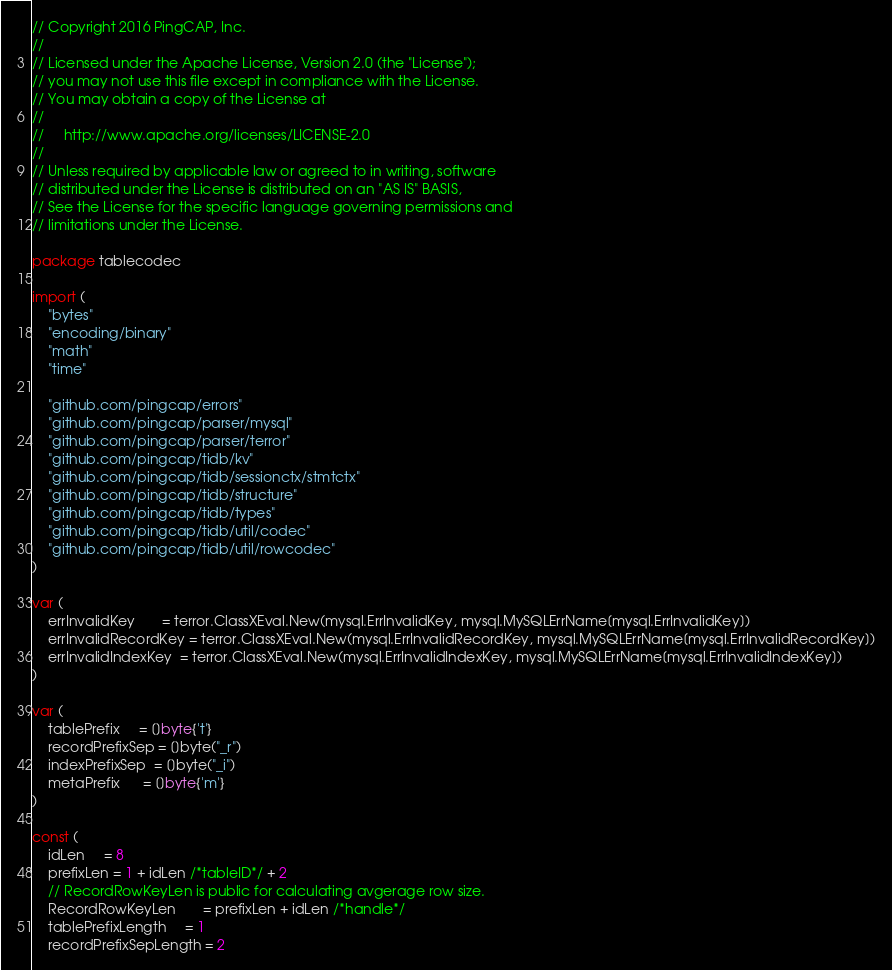<code> <loc_0><loc_0><loc_500><loc_500><_Go_>// Copyright 2016 PingCAP, Inc.
//
// Licensed under the Apache License, Version 2.0 (the "License");
// you may not use this file except in compliance with the License.
// You may obtain a copy of the License at
//
//     http://www.apache.org/licenses/LICENSE-2.0
//
// Unless required by applicable law or agreed to in writing, software
// distributed under the License is distributed on an "AS IS" BASIS,
// See the License for the specific language governing permissions and
// limitations under the License.

package tablecodec

import (
	"bytes"
	"encoding/binary"
	"math"
	"time"

	"github.com/pingcap/errors"
	"github.com/pingcap/parser/mysql"
	"github.com/pingcap/parser/terror"
	"github.com/pingcap/tidb/kv"
	"github.com/pingcap/tidb/sessionctx/stmtctx"
	"github.com/pingcap/tidb/structure"
	"github.com/pingcap/tidb/types"
	"github.com/pingcap/tidb/util/codec"
	"github.com/pingcap/tidb/util/rowcodec"
)

var (
	errInvalidKey       = terror.ClassXEval.New(mysql.ErrInvalidKey, mysql.MySQLErrName[mysql.ErrInvalidKey])
	errInvalidRecordKey = terror.ClassXEval.New(mysql.ErrInvalidRecordKey, mysql.MySQLErrName[mysql.ErrInvalidRecordKey])
	errInvalidIndexKey  = terror.ClassXEval.New(mysql.ErrInvalidIndexKey, mysql.MySQLErrName[mysql.ErrInvalidIndexKey])
)

var (
	tablePrefix     = []byte{'t'}
	recordPrefixSep = []byte("_r")
	indexPrefixSep  = []byte("_i")
	metaPrefix      = []byte{'m'}
)

const (
	idLen     = 8
	prefixLen = 1 + idLen /*tableID*/ + 2
	// RecordRowKeyLen is public for calculating avgerage row size.
	RecordRowKeyLen       = prefixLen + idLen /*handle*/
	tablePrefixLength     = 1
	recordPrefixSepLength = 2</code> 